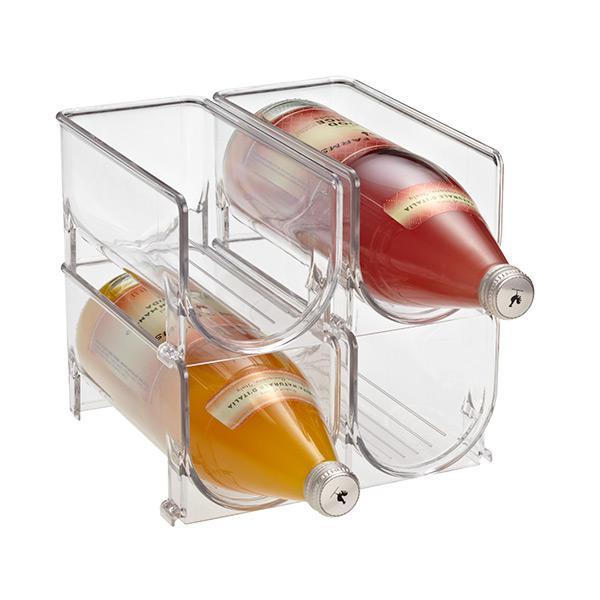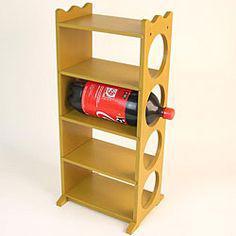The first image is the image on the left, the second image is the image on the right. Evaluate the accuracy of this statement regarding the images: "There are exactly five bottles of soda.". Is it true? Answer yes or no. No. The first image is the image on the left, the second image is the image on the right. Considering the images on both sides, is "In one of the images, a single red cola bottle sits on the second highest shelf of a shelf stack with 4 shelves on it." valid? Answer yes or no. Yes. 